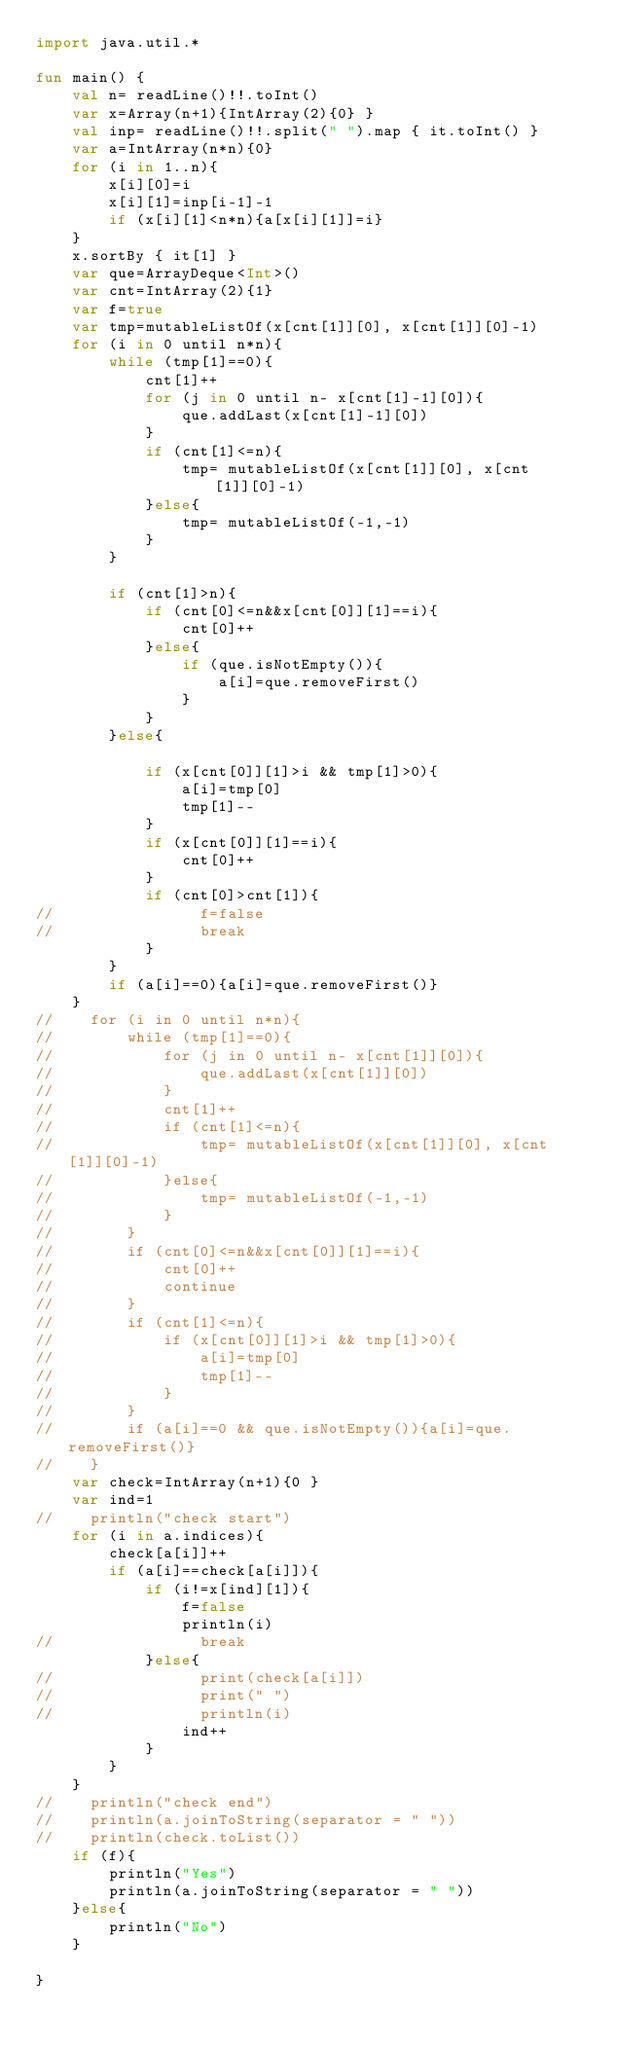Convert code to text. <code><loc_0><loc_0><loc_500><loc_500><_Kotlin_>import java.util.*

fun main() {
    val n= readLine()!!.toInt()
    var x=Array(n+1){IntArray(2){0} }
    val inp= readLine()!!.split(" ").map { it.toInt() }
    var a=IntArray(n*n){0}
    for (i in 1..n){
        x[i][0]=i
        x[i][1]=inp[i-1]-1
        if (x[i][1]<n*n){a[x[i][1]]=i}
    }
    x.sortBy { it[1] }
    var que=ArrayDeque<Int>()
    var cnt=IntArray(2){1}
    var f=true
    var tmp=mutableListOf(x[cnt[1]][0], x[cnt[1]][0]-1)
    for (i in 0 until n*n){
        while (tmp[1]==0){
            cnt[1]++
            for (j in 0 until n- x[cnt[1]-1][0]){
                que.addLast(x[cnt[1]-1][0])
            }
            if (cnt[1]<=n){
                tmp= mutableListOf(x[cnt[1]][0], x[cnt[1]][0]-1)
            }else{
                tmp= mutableListOf(-1,-1)
            }   
        }

        if (cnt[1]>n){
            if (cnt[0]<=n&&x[cnt[0]][1]==i){
                cnt[0]++
            }else{
                if (que.isNotEmpty()){
                    a[i]=que.removeFirst()
                }
            }
        }else{

            if (x[cnt[0]][1]>i && tmp[1]>0){
                a[i]=tmp[0]
                tmp[1]--
            }
            if (x[cnt[0]][1]==i){
                cnt[0]++
            }
            if (cnt[0]>cnt[1]){
//                f=false
//                break
            }
        }
        if (a[i]==0){a[i]=que.removeFirst()}
    }
//    for (i in 0 until n*n){
//        while (tmp[1]==0){
//            for (j in 0 until n- x[cnt[1]][0]){
//                que.addLast(x[cnt[1]][0])
//            }
//            cnt[1]++
//            if (cnt[1]<=n){
//                tmp= mutableListOf(x[cnt[1]][0], x[cnt[1]][0]-1)
//            }else{
//                tmp= mutableListOf(-1,-1)
//            }
//        }
//        if (cnt[0]<=n&&x[cnt[0]][1]==i){
//            cnt[0]++
//            continue
//        }
//        if (cnt[1]<=n){
//            if (x[cnt[0]][1]>i && tmp[1]>0){
//                a[i]=tmp[0]
//                tmp[1]--
//            }
//        }
//        if (a[i]==0 && que.isNotEmpty()){a[i]=que.removeFirst()}
//    }
    var check=IntArray(n+1){0 }
    var ind=1
//    println("check start")
    for (i in a.indices){
        check[a[i]]++
        if (a[i]==check[a[i]]){
            if (i!=x[ind][1]){
                f=false
                println(i)
//                break
            }else{
//                print(check[a[i]])
//                print(" ")
//                println(i)
                ind++
            }
        }
    }
//    println("check end")
//    println(a.joinToString(separator = " "))
//    println(check.toList())
    if (f){
        println("Yes")
        println(a.joinToString(separator = " "))
    }else{
        println("No")
    }

}</code> 